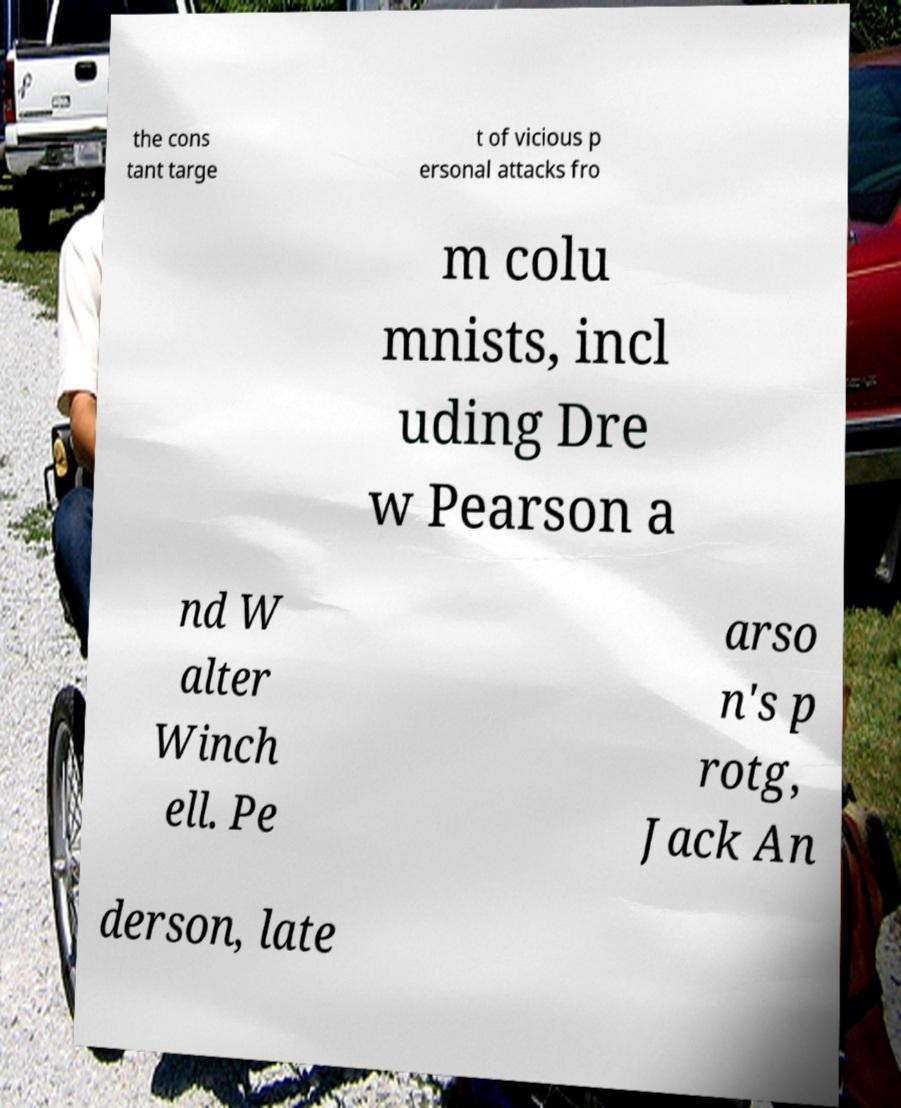What messages or text are displayed in this image? I need them in a readable, typed format. the cons tant targe t of vicious p ersonal attacks fro m colu mnists, incl uding Dre w Pearson a nd W alter Winch ell. Pe arso n's p rotg, Jack An derson, late 